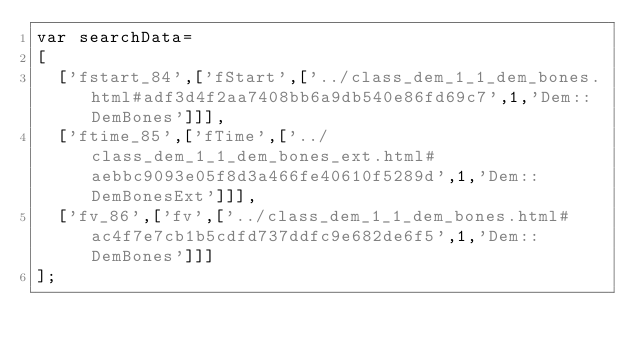<code> <loc_0><loc_0><loc_500><loc_500><_JavaScript_>var searchData=
[
  ['fstart_84',['fStart',['../class_dem_1_1_dem_bones.html#adf3d4f2aa7408bb6a9db540e86fd69c7',1,'Dem::DemBones']]],
  ['ftime_85',['fTime',['../class_dem_1_1_dem_bones_ext.html#aebbc9093e05f8d3a466fe40610f5289d',1,'Dem::DemBonesExt']]],
  ['fv_86',['fv',['../class_dem_1_1_dem_bones.html#ac4f7e7cb1b5cdfd737ddfc9e682de6f5',1,'Dem::DemBones']]]
];
</code> 